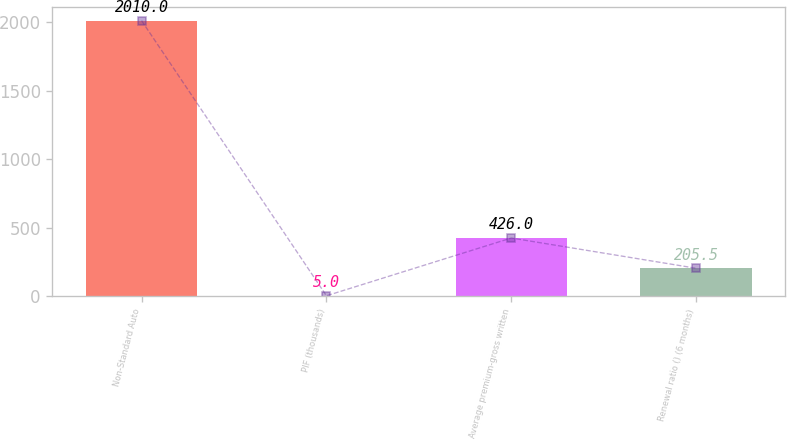Convert chart. <chart><loc_0><loc_0><loc_500><loc_500><bar_chart><fcel>Non-Standard Auto<fcel>PIF (thousands)<fcel>Average premium-gross written<fcel>Renewal ratio () (6 months)<nl><fcel>2010<fcel>5<fcel>426<fcel>205.5<nl></chart> 